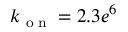<formula> <loc_0><loc_0><loc_500><loc_500>k _ { o n } = 2 . 3 e ^ { 6 }</formula> 